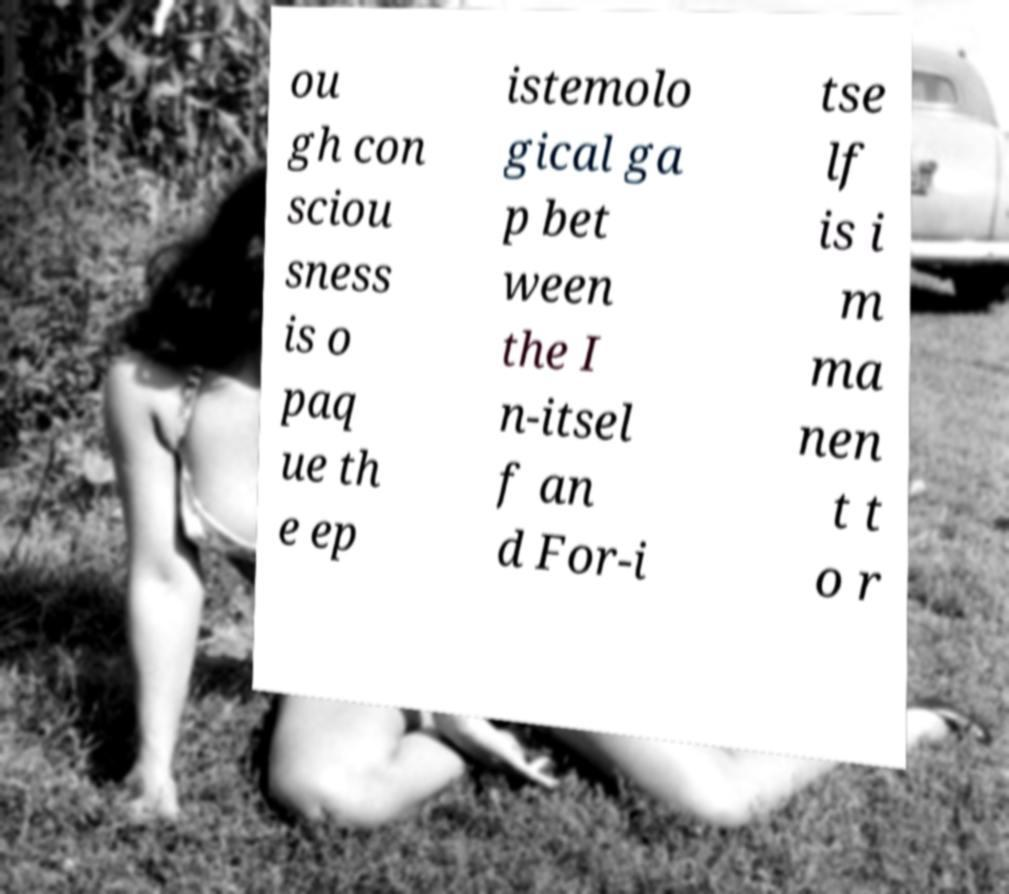Please identify and transcribe the text found in this image. ou gh con sciou sness is o paq ue th e ep istemolo gical ga p bet ween the I n-itsel f an d For-i tse lf is i m ma nen t t o r 